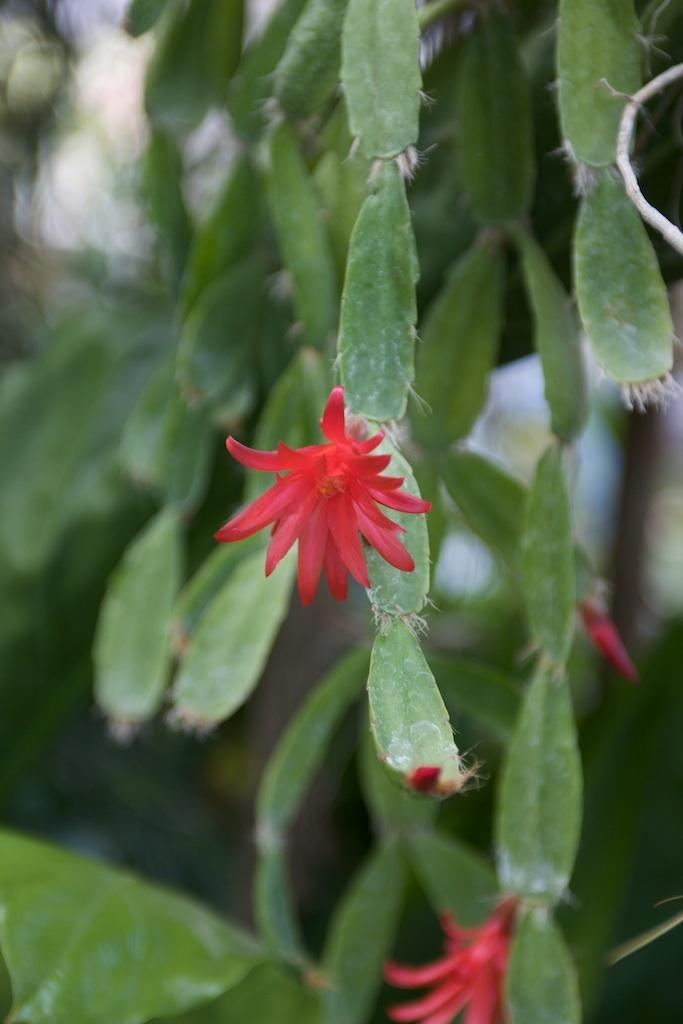What type of plant is in the image? There is an orchid cactus in the image. What color is the flower on the plant? There is a red flower in the image. What type of shade is provided by the roof in the image? There is no roof or shade mentioned in the image; it only features an orchid cactus with a red flower. 